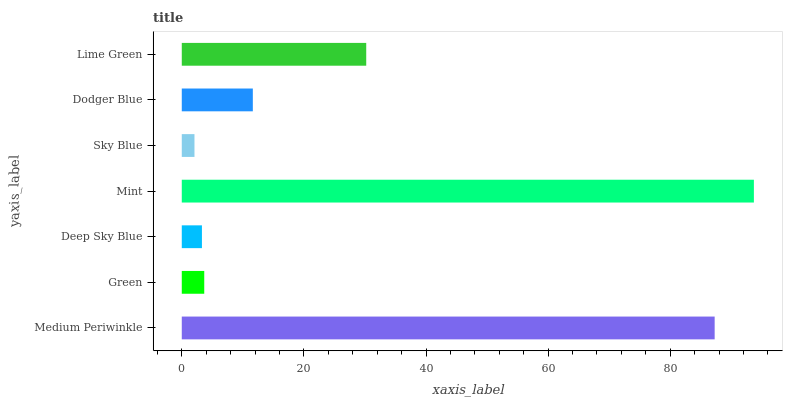Is Sky Blue the minimum?
Answer yes or no. Yes. Is Mint the maximum?
Answer yes or no. Yes. Is Green the minimum?
Answer yes or no. No. Is Green the maximum?
Answer yes or no. No. Is Medium Periwinkle greater than Green?
Answer yes or no. Yes. Is Green less than Medium Periwinkle?
Answer yes or no. Yes. Is Green greater than Medium Periwinkle?
Answer yes or no. No. Is Medium Periwinkle less than Green?
Answer yes or no. No. Is Dodger Blue the high median?
Answer yes or no. Yes. Is Dodger Blue the low median?
Answer yes or no. Yes. Is Deep Sky Blue the high median?
Answer yes or no. No. Is Mint the low median?
Answer yes or no. No. 